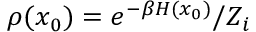<formula> <loc_0><loc_0><loc_500><loc_500>\rho ( x _ { 0 } ) = e ^ { - \beta H ( x _ { 0 } ) } / Z _ { i }</formula> 